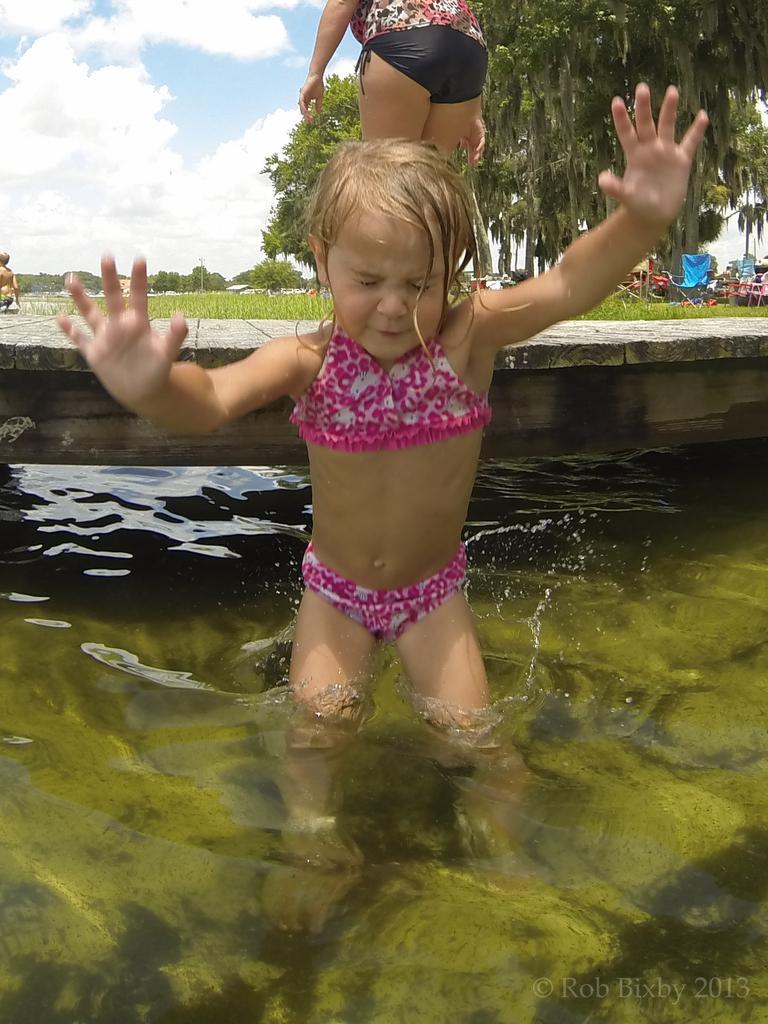Can you describe this image briefly? In the foreground of this image, there is a girl in the water. Behind her, there is a dock, a woman standing, grass, trees, few objects and the sky. On the left, it seems like there is a person. 